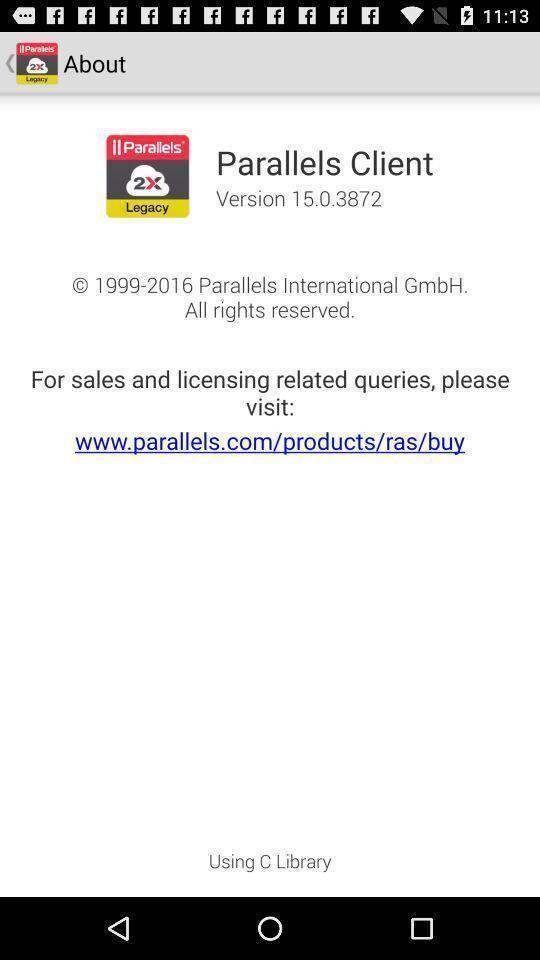Describe the content in this image. Screen shows details about an app. 